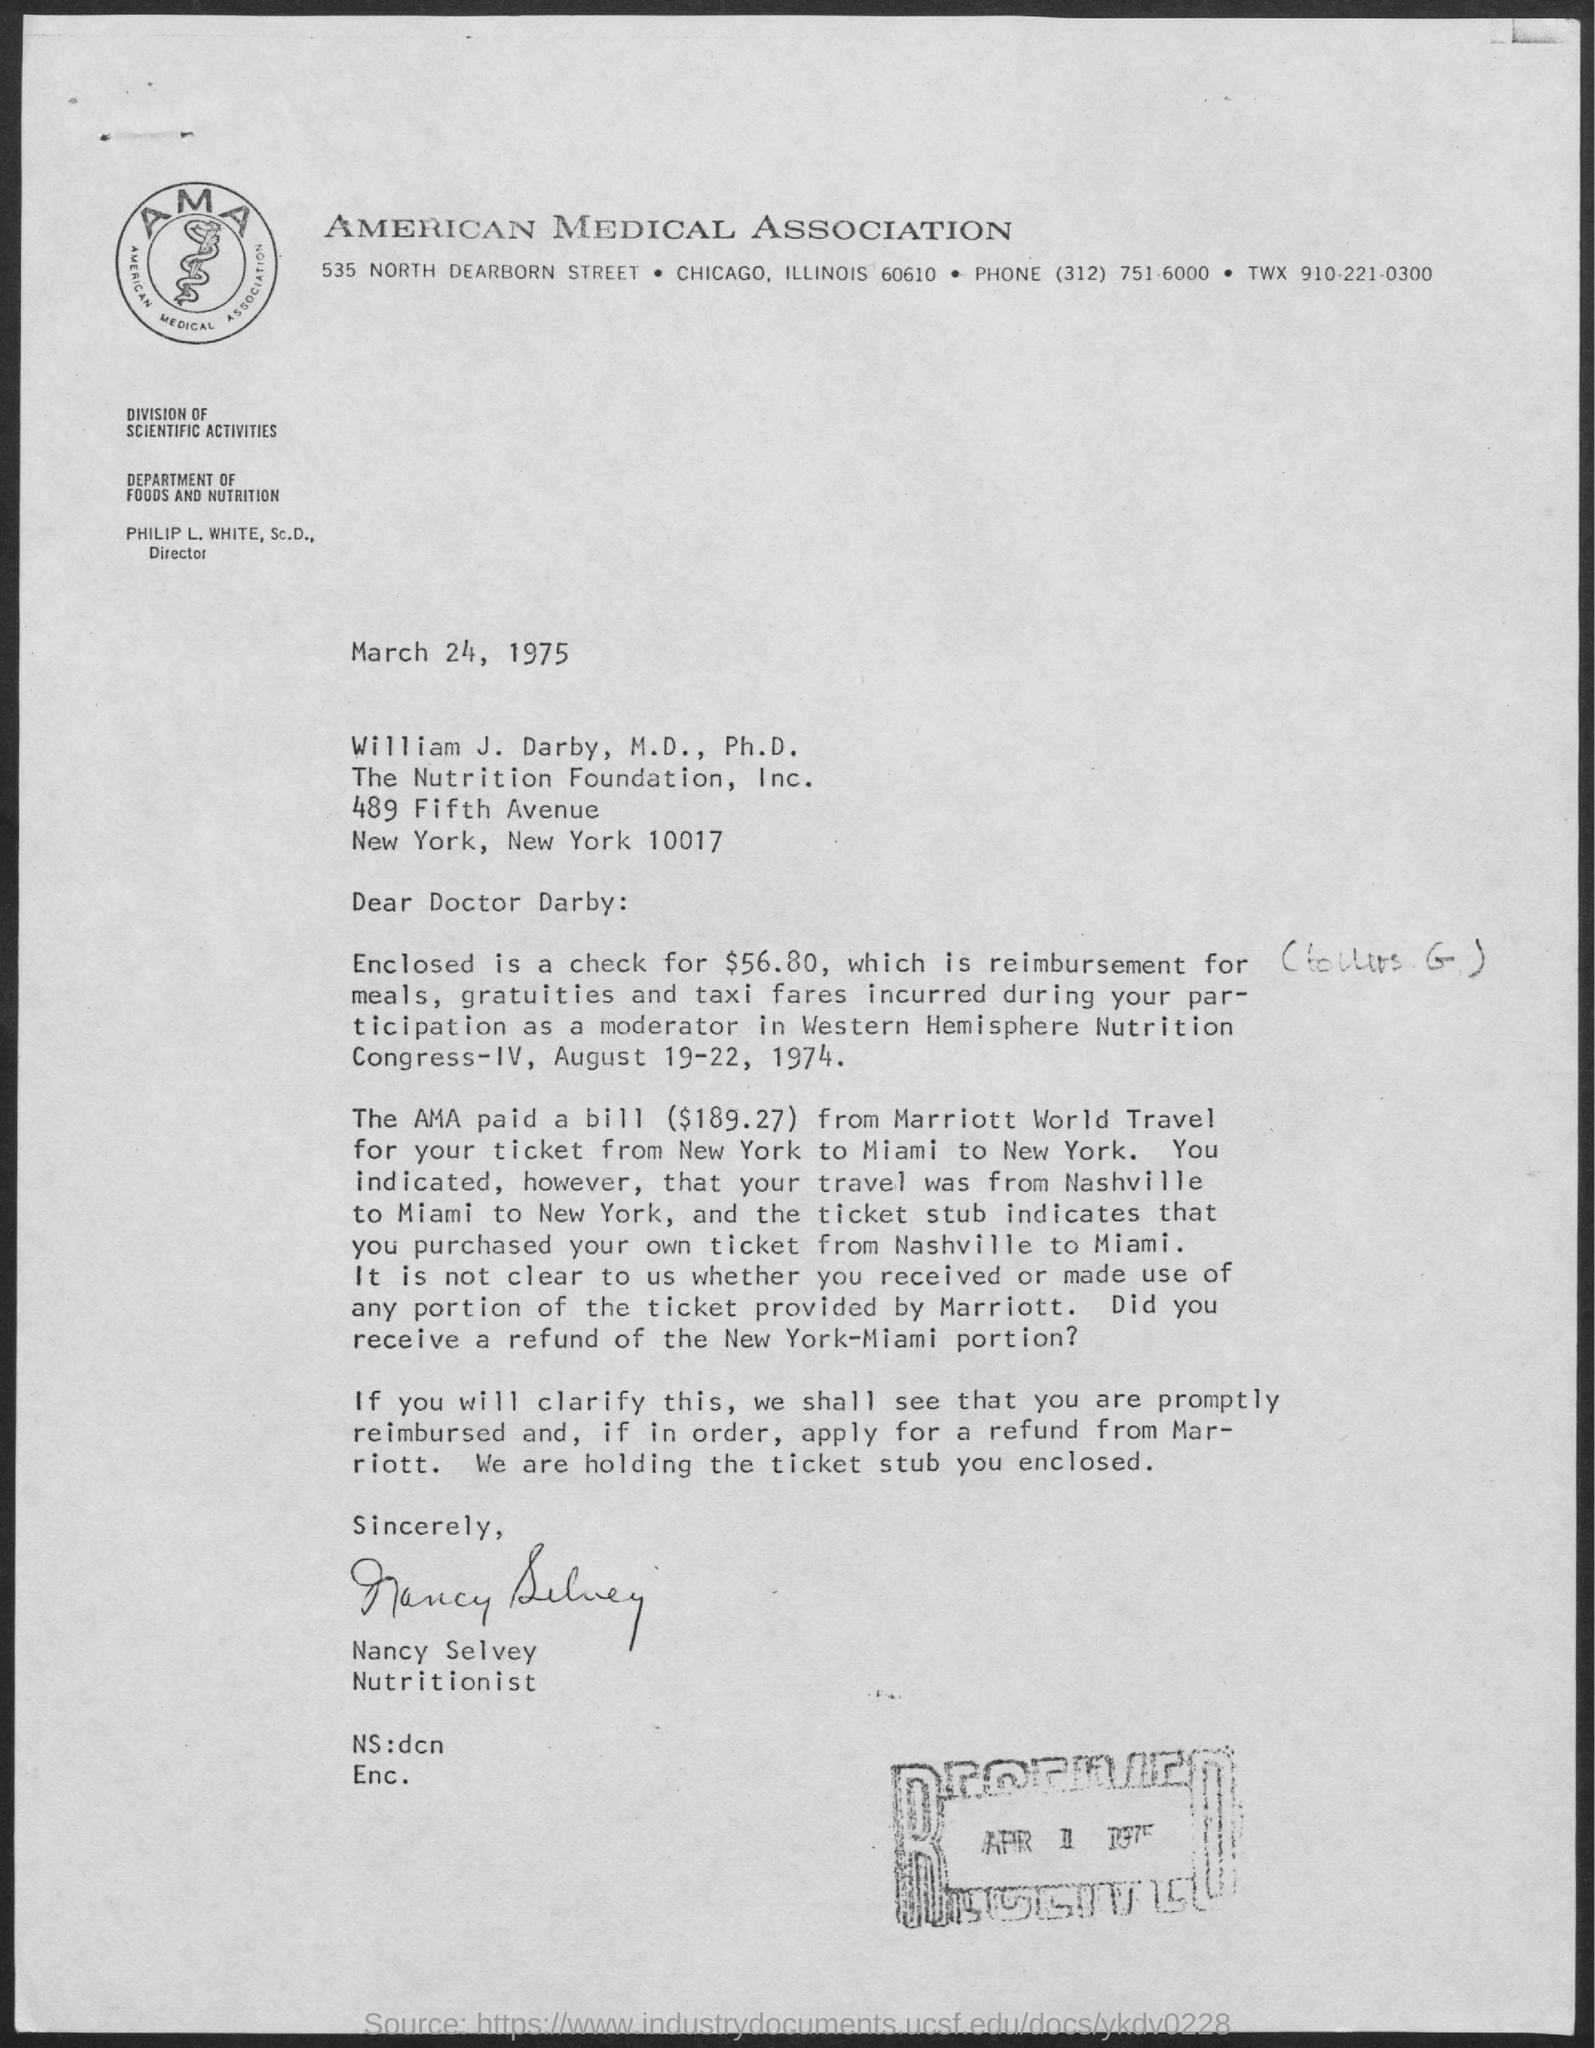What is the title of the document ?
Ensure brevity in your answer.  AMERICAN MEDICAL ASSOCIATION. What is the date mentioned in the top of the document ?
Provide a succinct answer. March 24, 1975. 